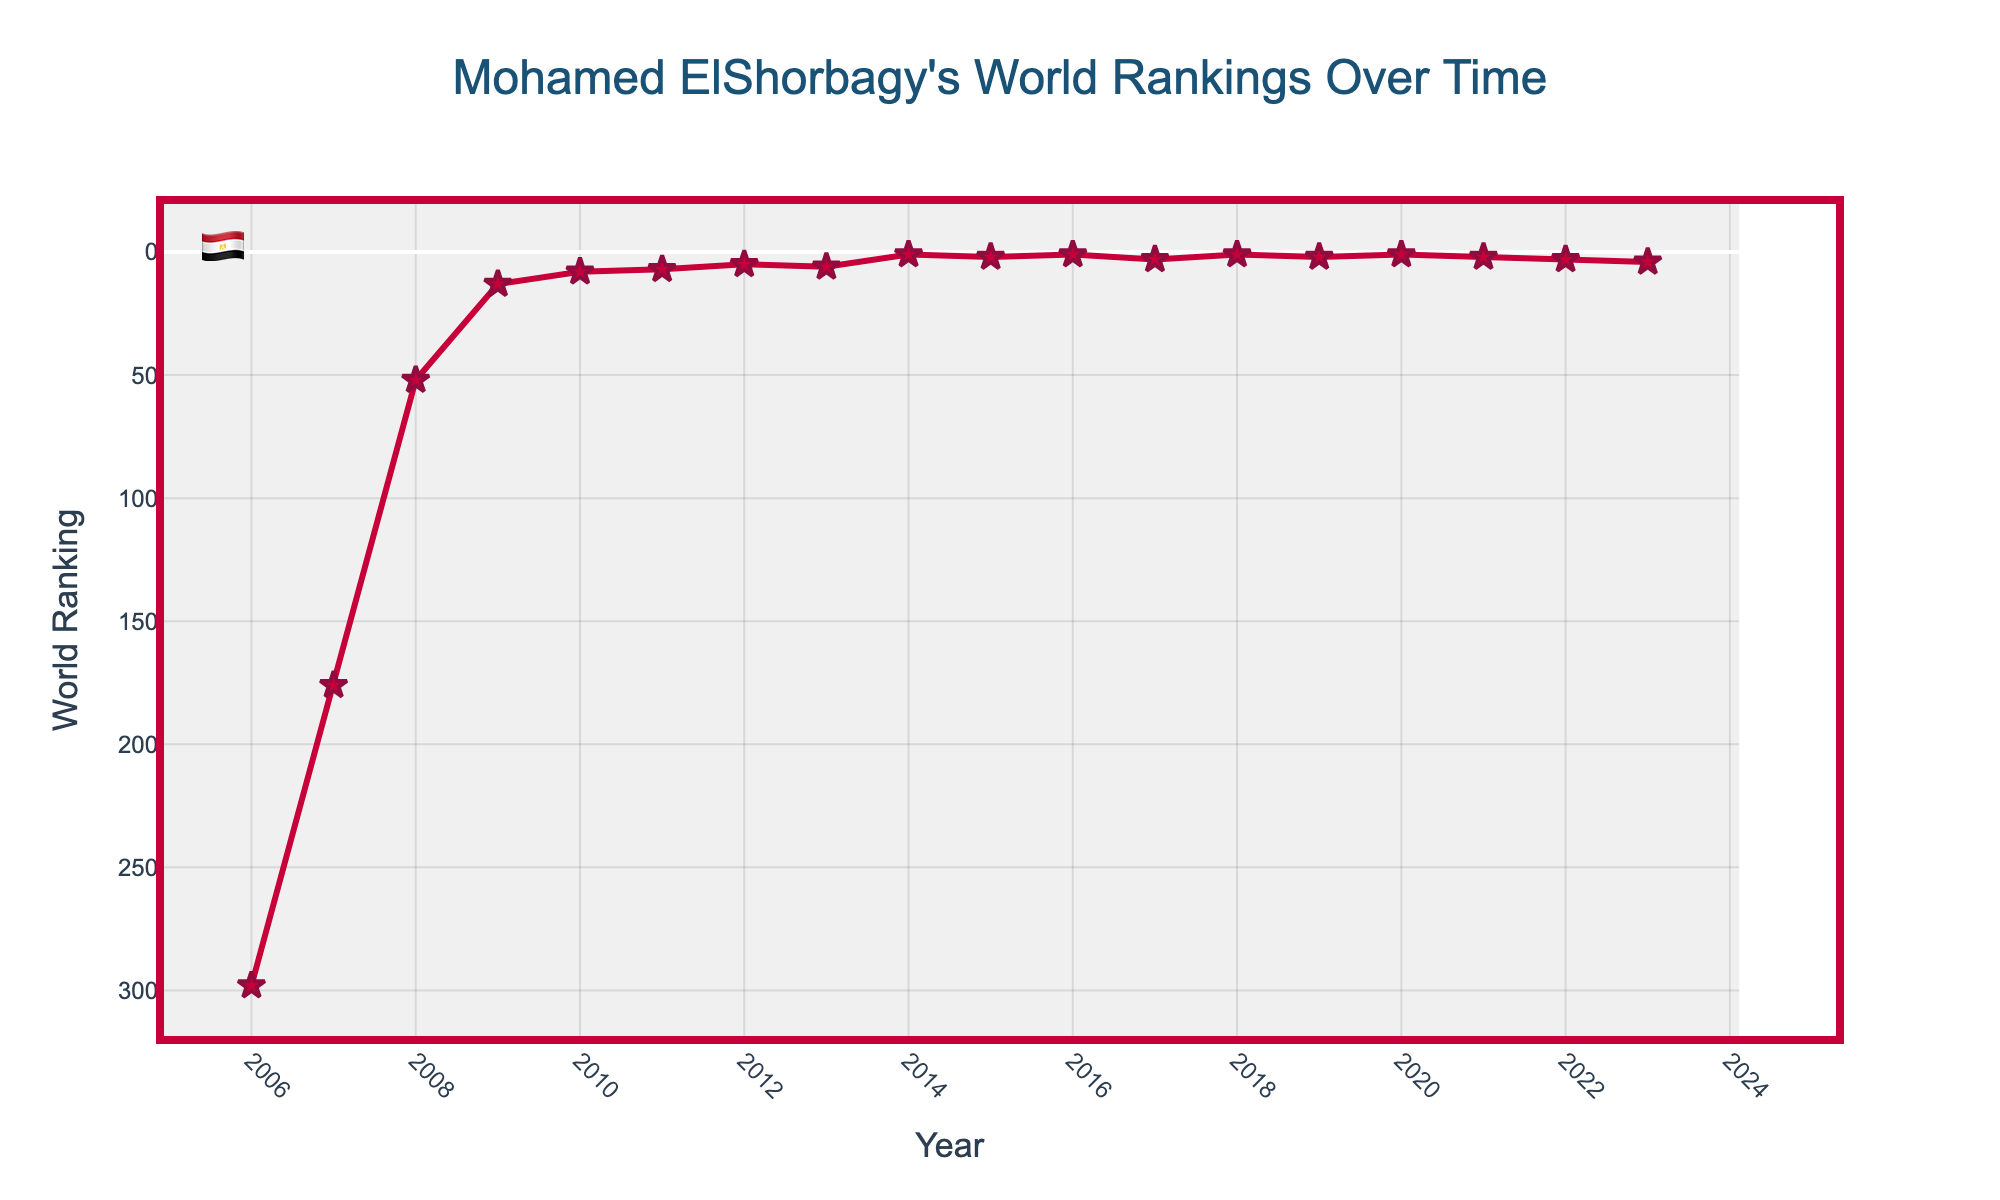What's the highest world ranking Mohamed ElShorbagy achieved according to the figure? By looking at the vertical axis (World Ranking) and the plotted line, we can determine the highest rank he achieved. The lowest point on the y-axis is 1, which indicates that he achieved a world ranking of 1.
Answer: 1 What was Mohamed ElShorbagy's world ranking in the year 2014? We can find the data point corresponding to the year 2014 on the x-axis and look at its y value on the World Ranking axis. For 2014, the y value is 1.
Answer: 1 How many times did Mohamed ElShorbagy reach the world ranking of 1? By examining the figure, we count the number of times the line hits the value 1 on the y-axis over different years. The years are 2014, 2016, 2018, and 2020.
Answer: 4 In which year did Mohamed ElShorbagy first break into the top 10 world rankings? We need to find the first year where his world ranking is less than or equal to 10 by examining the y values corresponding to each year. The first such y value is in 2010 with a ranking of 8 according to the plot.
Answer: 2010 What trend do you notice in Mohamed ElShorbagy's world ranking from 2006 to 2010? Observing the figure from 2006 to 2010, the y values decrease steadily, indicating an improvement in his ranking over each year, moving from 298 in 2006 to 8 in 2010.
Answer: Improvement Between which two consecutive years did Mohamed ElShorbagy make the biggest jump in his world ranking? By comparing differences in rankings between consecutive years, the biggest drop in the y value (ranking number) is between 2008 (52) and 2009 (13), which is a jump of 39 ranks.
Answer: 2008 to 2009 From the line chart, when was the last time Mohamed ElShorbagy held the number 1 world ranking? Looking at the highest (lowest y) points on the chart, the last year he held the number 1 ranking is 2020.
Answer: 2020 What was Mohamed ElShorbagy's world ranking trend from 2009 to 2012? From 2009 to 2010, his ranking improves (13 to 8), continues to improve in 2011 (7), and then reaches 5 in 2012. Overall, his ranking improves throughout these years.
Answer: Improvement What is the average world ranking of Mohamed ElShorbagy from 2006 to 2010? Add the rankings for these years and divide by the number of years: (298 + 176 + 52 + 13 + 8) / 5 = 547 / 5 = 109.4
Answer: 109.4 